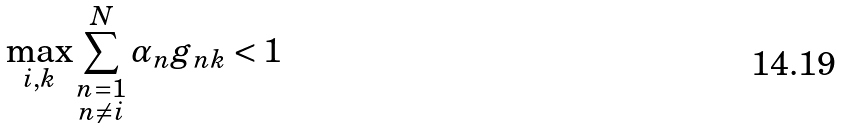Convert formula to latex. <formula><loc_0><loc_0><loc_500><loc_500>\max _ { i , k } \sum _ { \substack { n = 1 \\ n \neq i } } ^ { N } \alpha _ { n } g _ { n k } < 1</formula> 